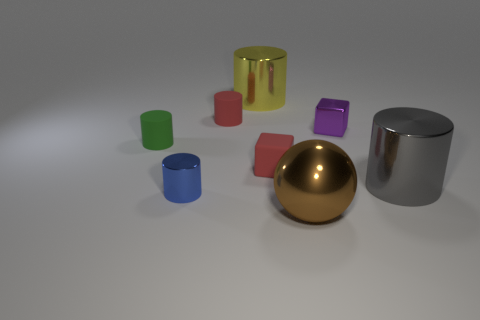There is a tiny rubber cube; is its color the same as the small shiny thing that is on the left side of the metal ball?
Your answer should be compact. No. How many metal cubes are there?
Give a very brief answer. 1. What number of objects are green things or small blue cylinders?
Your answer should be very brief. 2. What is the size of the matte thing that is the same color as the tiny matte cube?
Give a very brief answer. Small. There is a tiny purple thing; are there any large metallic cylinders left of it?
Provide a succinct answer. Yes. Are there more large brown objects right of the tiny purple block than cylinders that are on the left side of the large brown object?
Keep it short and to the point. No. There is a gray shiny object that is the same shape as the yellow thing; what size is it?
Offer a terse response. Large. What number of cylinders are either green matte things or tiny purple things?
Make the answer very short. 1. There is a tiny thing that is the same color as the tiny matte block; what is it made of?
Provide a short and direct response. Rubber. Are there fewer small red rubber objects that are right of the brown sphere than shiny cylinders to the left of the gray metallic cylinder?
Give a very brief answer. Yes. 